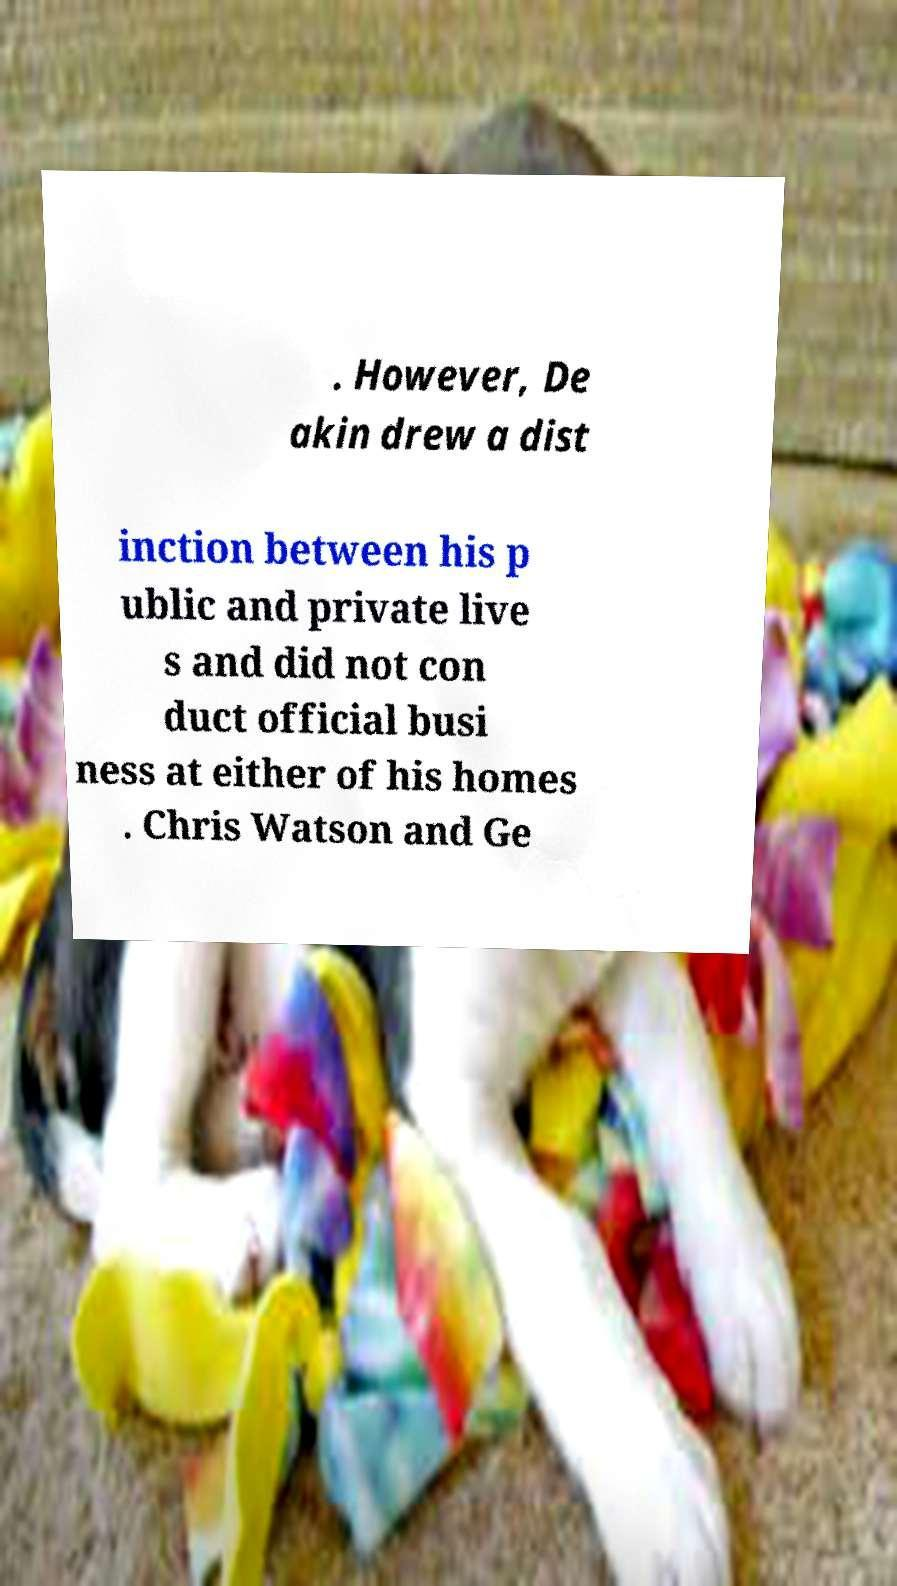There's text embedded in this image that I need extracted. Can you transcribe it verbatim? . However, De akin drew a dist inction between his p ublic and private live s and did not con duct official busi ness at either of his homes . Chris Watson and Ge 